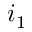Convert formula to latex. <formula><loc_0><loc_0><loc_500><loc_500>i _ { 1 }</formula> 